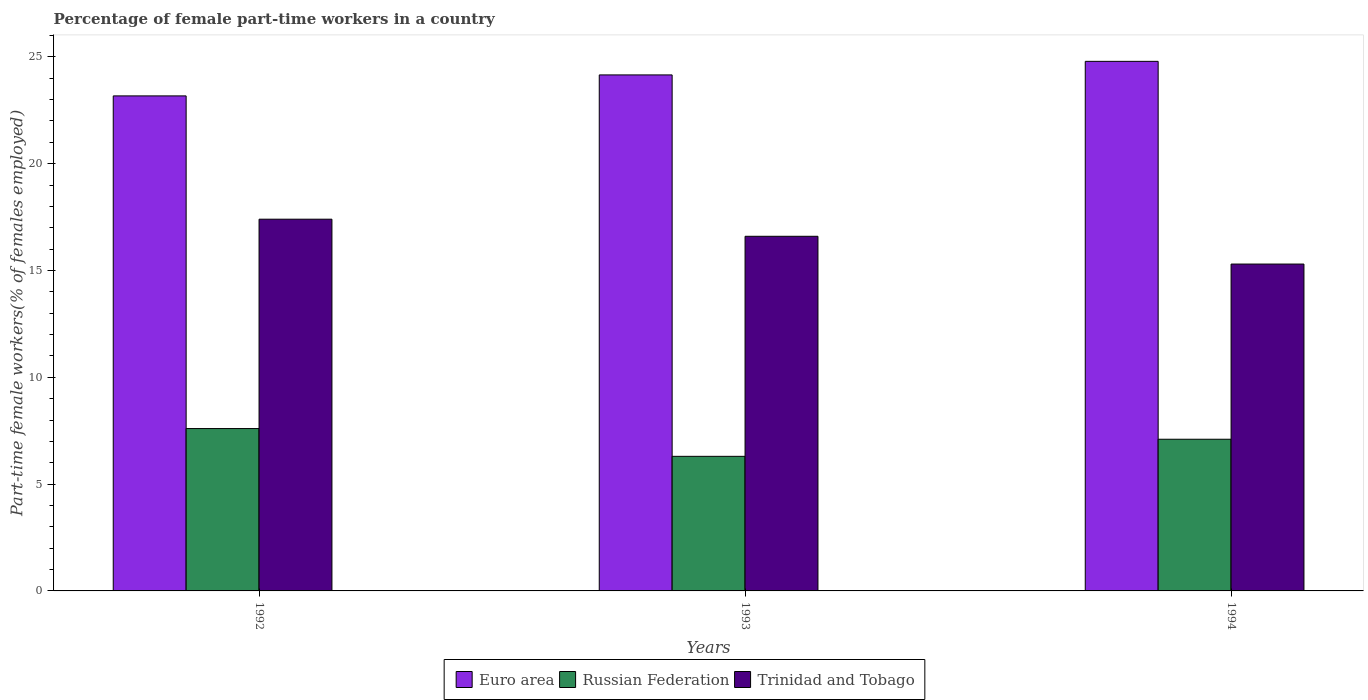How many groups of bars are there?
Keep it short and to the point. 3. Are the number of bars per tick equal to the number of legend labels?
Your answer should be very brief. Yes. How many bars are there on the 1st tick from the left?
Offer a very short reply. 3. In how many cases, is the number of bars for a given year not equal to the number of legend labels?
Provide a succinct answer. 0. What is the percentage of female part-time workers in Russian Federation in 1993?
Your answer should be very brief. 6.3. Across all years, what is the maximum percentage of female part-time workers in Trinidad and Tobago?
Your answer should be compact. 17.4. Across all years, what is the minimum percentage of female part-time workers in Russian Federation?
Keep it short and to the point. 6.3. In which year was the percentage of female part-time workers in Trinidad and Tobago maximum?
Make the answer very short. 1992. In which year was the percentage of female part-time workers in Trinidad and Tobago minimum?
Your response must be concise. 1994. What is the total percentage of female part-time workers in Russian Federation in the graph?
Keep it short and to the point. 21. What is the difference between the percentage of female part-time workers in Trinidad and Tobago in 1993 and that in 1994?
Your answer should be very brief. 1.3. What is the difference between the percentage of female part-time workers in Russian Federation in 1992 and the percentage of female part-time workers in Trinidad and Tobago in 1994?
Offer a very short reply. -7.7. What is the average percentage of female part-time workers in Trinidad and Tobago per year?
Ensure brevity in your answer.  16.43. In the year 1993, what is the difference between the percentage of female part-time workers in Euro area and percentage of female part-time workers in Russian Federation?
Provide a short and direct response. 17.85. In how many years, is the percentage of female part-time workers in Euro area greater than 2 %?
Provide a short and direct response. 3. What is the ratio of the percentage of female part-time workers in Euro area in 1992 to that in 1993?
Offer a very short reply. 0.96. Is the percentage of female part-time workers in Euro area in 1993 less than that in 1994?
Your answer should be compact. Yes. Is the difference between the percentage of female part-time workers in Euro area in 1992 and 1993 greater than the difference between the percentage of female part-time workers in Russian Federation in 1992 and 1993?
Ensure brevity in your answer.  No. What is the difference between the highest and the second highest percentage of female part-time workers in Euro area?
Your answer should be compact. 0.63. What is the difference between the highest and the lowest percentage of female part-time workers in Trinidad and Tobago?
Offer a very short reply. 2.1. In how many years, is the percentage of female part-time workers in Euro area greater than the average percentage of female part-time workers in Euro area taken over all years?
Give a very brief answer. 2. Is the sum of the percentage of female part-time workers in Russian Federation in 1992 and 1994 greater than the maximum percentage of female part-time workers in Trinidad and Tobago across all years?
Make the answer very short. No. What does the 3rd bar from the left in 1992 represents?
Your response must be concise. Trinidad and Tobago. How many bars are there?
Your answer should be compact. 9. Are all the bars in the graph horizontal?
Make the answer very short. No. How many legend labels are there?
Provide a short and direct response. 3. What is the title of the graph?
Offer a terse response. Percentage of female part-time workers in a country. Does "Venezuela" appear as one of the legend labels in the graph?
Your answer should be compact. No. What is the label or title of the Y-axis?
Your answer should be compact. Part-time female workers(% of females employed). What is the Part-time female workers(% of females employed) in Euro area in 1992?
Your response must be concise. 23.17. What is the Part-time female workers(% of females employed) in Russian Federation in 1992?
Give a very brief answer. 7.6. What is the Part-time female workers(% of females employed) of Trinidad and Tobago in 1992?
Your answer should be compact. 17.4. What is the Part-time female workers(% of females employed) in Euro area in 1993?
Provide a short and direct response. 24.15. What is the Part-time female workers(% of females employed) in Russian Federation in 1993?
Make the answer very short. 6.3. What is the Part-time female workers(% of females employed) of Trinidad and Tobago in 1993?
Keep it short and to the point. 16.6. What is the Part-time female workers(% of females employed) in Euro area in 1994?
Your answer should be compact. 24.79. What is the Part-time female workers(% of females employed) of Russian Federation in 1994?
Your answer should be very brief. 7.1. What is the Part-time female workers(% of females employed) in Trinidad and Tobago in 1994?
Your answer should be compact. 15.3. Across all years, what is the maximum Part-time female workers(% of females employed) of Euro area?
Provide a succinct answer. 24.79. Across all years, what is the maximum Part-time female workers(% of females employed) of Russian Federation?
Ensure brevity in your answer.  7.6. Across all years, what is the maximum Part-time female workers(% of females employed) of Trinidad and Tobago?
Your response must be concise. 17.4. Across all years, what is the minimum Part-time female workers(% of females employed) of Euro area?
Your answer should be very brief. 23.17. Across all years, what is the minimum Part-time female workers(% of females employed) in Russian Federation?
Offer a very short reply. 6.3. Across all years, what is the minimum Part-time female workers(% of females employed) of Trinidad and Tobago?
Ensure brevity in your answer.  15.3. What is the total Part-time female workers(% of females employed) in Euro area in the graph?
Give a very brief answer. 72.11. What is the total Part-time female workers(% of females employed) in Russian Federation in the graph?
Offer a terse response. 21. What is the total Part-time female workers(% of females employed) in Trinidad and Tobago in the graph?
Make the answer very short. 49.3. What is the difference between the Part-time female workers(% of females employed) in Euro area in 1992 and that in 1993?
Offer a terse response. -0.98. What is the difference between the Part-time female workers(% of females employed) of Euro area in 1992 and that in 1994?
Ensure brevity in your answer.  -1.62. What is the difference between the Part-time female workers(% of females employed) of Euro area in 1993 and that in 1994?
Your answer should be very brief. -0.63. What is the difference between the Part-time female workers(% of females employed) in Russian Federation in 1993 and that in 1994?
Keep it short and to the point. -0.8. What is the difference between the Part-time female workers(% of females employed) of Trinidad and Tobago in 1993 and that in 1994?
Offer a very short reply. 1.3. What is the difference between the Part-time female workers(% of females employed) of Euro area in 1992 and the Part-time female workers(% of females employed) of Russian Federation in 1993?
Provide a short and direct response. 16.87. What is the difference between the Part-time female workers(% of females employed) in Euro area in 1992 and the Part-time female workers(% of females employed) in Trinidad and Tobago in 1993?
Your answer should be compact. 6.57. What is the difference between the Part-time female workers(% of females employed) of Euro area in 1992 and the Part-time female workers(% of females employed) of Russian Federation in 1994?
Make the answer very short. 16.07. What is the difference between the Part-time female workers(% of females employed) of Euro area in 1992 and the Part-time female workers(% of females employed) of Trinidad and Tobago in 1994?
Offer a very short reply. 7.87. What is the difference between the Part-time female workers(% of females employed) in Russian Federation in 1992 and the Part-time female workers(% of females employed) in Trinidad and Tobago in 1994?
Provide a succinct answer. -7.7. What is the difference between the Part-time female workers(% of females employed) of Euro area in 1993 and the Part-time female workers(% of females employed) of Russian Federation in 1994?
Your answer should be very brief. 17.05. What is the difference between the Part-time female workers(% of females employed) in Euro area in 1993 and the Part-time female workers(% of females employed) in Trinidad and Tobago in 1994?
Provide a short and direct response. 8.85. What is the average Part-time female workers(% of females employed) of Euro area per year?
Provide a short and direct response. 24.04. What is the average Part-time female workers(% of females employed) of Russian Federation per year?
Your answer should be very brief. 7. What is the average Part-time female workers(% of females employed) in Trinidad and Tobago per year?
Offer a terse response. 16.43. In the year 1992, what is the difference between the Part-time female workers(% of females employed) of Euro area and Part-time female workers(% of females employed) of Russian Federation?
Your answer should be compact. 15.57. In the year 1992, what is the difference between the Part-time female workers(% of females employed) in Euro area and Part-time female workers(% of females employed) in Trinidad and Tobago?
Offer a terse response. 5.77. In the year 1992, what is the difference between the Part-time female workers(% of females employed) in Russian Federation and Part-time female workers(% of females employed) in Trinidad and Tobago?
Your response must be concise. -9.8. In the year 1993, what is the difference between the Part-time female workers(% of females employed) in Euro area and Part-time female workers(% of females employed) in Russian Federation?
Offer a terse response. 17.85. In the year 1993, what is the difference between the Part-time female workers(% of females employed) in Euro area and Part-time female workers(% of females employed) in Trinidad and Tobago?
Keep it short and to the point. 7.55. In the year 1994, what is the difference between the Part-time female workers(% of females employed) in Euro area and Part-time female workers(% of females employed) in Russian Federation?
Make the answer very short. 17.69. In the year 1994, what is the difference between the Part-time female workers(% of females employed) in Euro area and Part-time female workers(% of females employed) in Trinidad and Tobago?
Your answer should be very brief. 9.49. In the year 1994, what is the difference between the Part-time female workers(% of females employed) in Russian Federation and Part-time female workers(% of females employed) in Trinidad and Tobago?
Ensure brevity in your answer.  -8.2. What is the ratio of the Part-time female workers(% of females employed) of Euro area in 1992 to that in 1993?
Give a very brief answer. 0.96. What is the ratio of the Part-time female workers(% of females employed) in Russian Federation in 1992 to that in 1993?
Offer a very short reply. 1.21. What is the ratio of the Part-time female workers(% of females employed) in Trinidad and Tobago in 1992 to that in 1993?
Your response must be concise. 1.05. What is the ratio of the Part-time female workers(% of females employed) of Euro area in 1992 to that in 1994?
Keep it short and to the point. 0.93. What is the ratio of the Part-time female workers(% of females employed) of Russian Federation in 1992 to that in 1994?
Keep it short and to the point. 1.07. What is the ratio of the Part-time female workers(% of females employed) of Trinidad and Tobago in 1992 to that in 1994?
Your response must be concise. 1.14. What is the ratio of the Part-time female workers(% of females employed) of Euro area in 1993 to that in 1994?
Offer a very short reply. 0.97. What is the ratio of the Part-time female workers(% of females employed) in Russian Federation in 1993 to that in 1994?
Ensure brevity in your answer.  0.89. What is the ratio of the Part-time female workers(% of females employed) of Trinidad and Tobago in 1993 to that in 1994?
Make the answer very short. 1.08. What is the difference between the highest and the second highest Part-time female workers(% of females employed) in Euro area?
Keep it short and to the point. 0.63. What is the difference between the highest and the second highest Part-time female workers(% of females employed) of Russian Federation?
Your answer should be compact. 0.5. What is the difference between the highest and the second highest Part-time female workers(% of females employed) of Trinidad and Tobago?
Offer a very short reply. 0.8. What is the difference between the highest and the lowest Part-time female workers(% of females employed) in Euro area?
Your answer should be very brief. 1.62. What is the difference between the highest and the lowest Part-time female workers(% of females employed) of Russian Federation?
Your answer should be very brief. 1.3. What is the difference between the highest and the lowest Part-time female workers(% of females employed) in Trinidad and Tobago?
Offer a terse response. 2.1. 